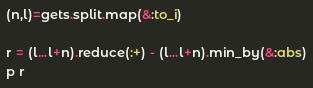Convert code to text. <code><loc_0><loc_0><loc_500><loc_500><_Ruby_>(n,l)=gets.split.map(&:to_i)

r = (l...l+n).reduce(:+) - (l...l+n).min_by(&:abs)
p r
</code> 